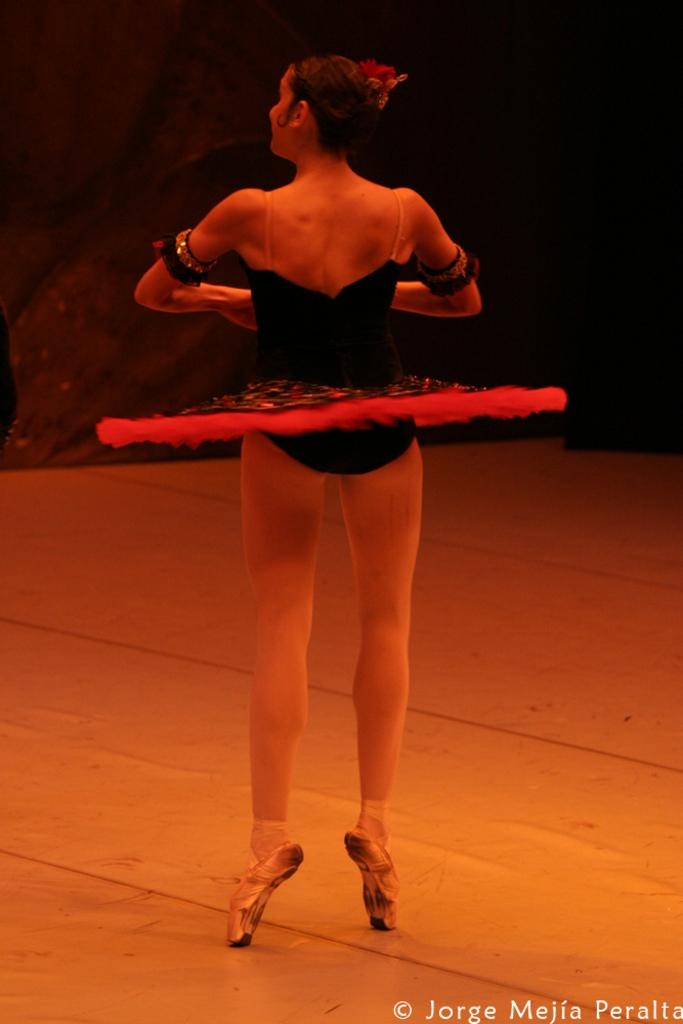What type of performer is in the image? There is a ballet dancer in the image. Can you describe the dancer's attire or pose? Unfortunately, the provided facts do not include information about the dancer's attire or pose. What type of sticks are being used by the dinosaurs in the image? There are no dinosaurs or sticks present in the image; it features a ballet dancer. 